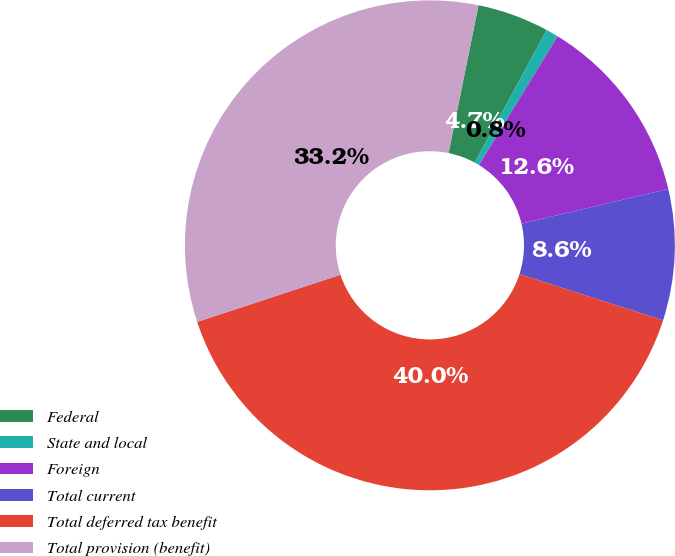Convert chart. <chart><loc_0><loc_0><loc_500><loc_500><pie_chart><fcel>Federal<fcel>State and local<fcel>Foreign<fcel>Total current<fcel>Total deferred tax benefit<fcel>Total provision (benefit)<nl><fcel>4.73%<fcel>0.82%<fcel>12.57%<fcel>8.65%<fcel>39.99%<fcel>33.24%<nl></chart> 